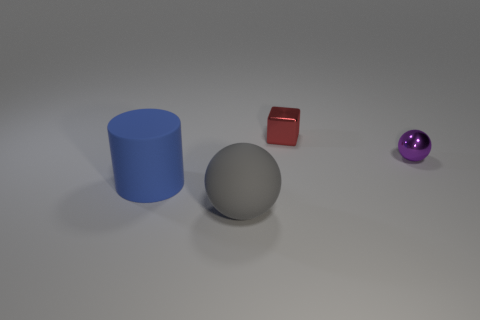Add 1 purple metallic things. How many objects exist? 5 Subtract all cubes. How many objects are left? 3 Add 2 cylinders. How many cylinders are left? 3 Add 4 large yellow cubes. How many large yellow cubes exist? 4 Subtract 0 blue cubes. How many objects are left? 4 Subtract all tiny red metal cubes. Subtract all large gray spheres. How many objects are left? 2 